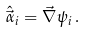<formula> <loc_0><loc_0><loc_500><loc_500>\hat { \vec { \alpha } } _ { i } = \vec { \nabla } \psi _ { i } \, .</formula> 